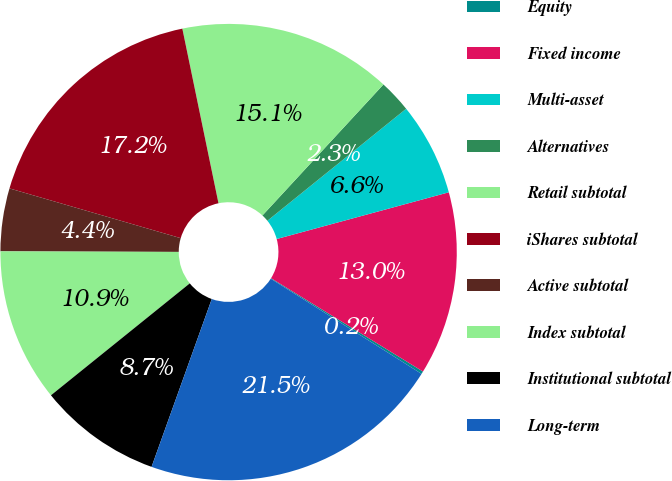Convert chart. <chart><loc_0><loc_0><loc_500><loc_500><pie_chart><fcel>Equity<fcel>Fixed income<fcel>Multi-asset<fcel>Alternatives<fcel>Retail subtotal<fcel>iShares subtotal<fcel>Active subtotal<fcel>Index subtotal<fcel>Institutional subtotal<fcel>Long-term<nl><fcel>0.19%<fcel>12.99%<fcel>6.59%<fcel>2.32%<fcel>15.12%<fcel>17.25%<fcel>4.45%<fcel>10.85%<fcel>8.72%<fcel>21.52%<nl></chart> 